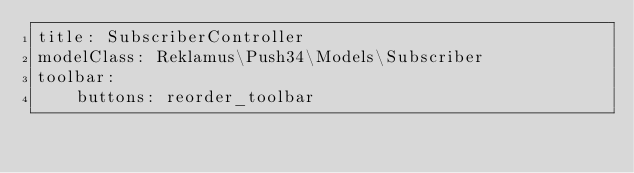Convert code to text. <code><loc_0><loc_0><loc_500><loc_500><_YAML_>title: SubscriberController
modelClass: Reklamus\Push34\Models\Subscriber
toolbar:
    buttons: reorder_toolbar
</code> 